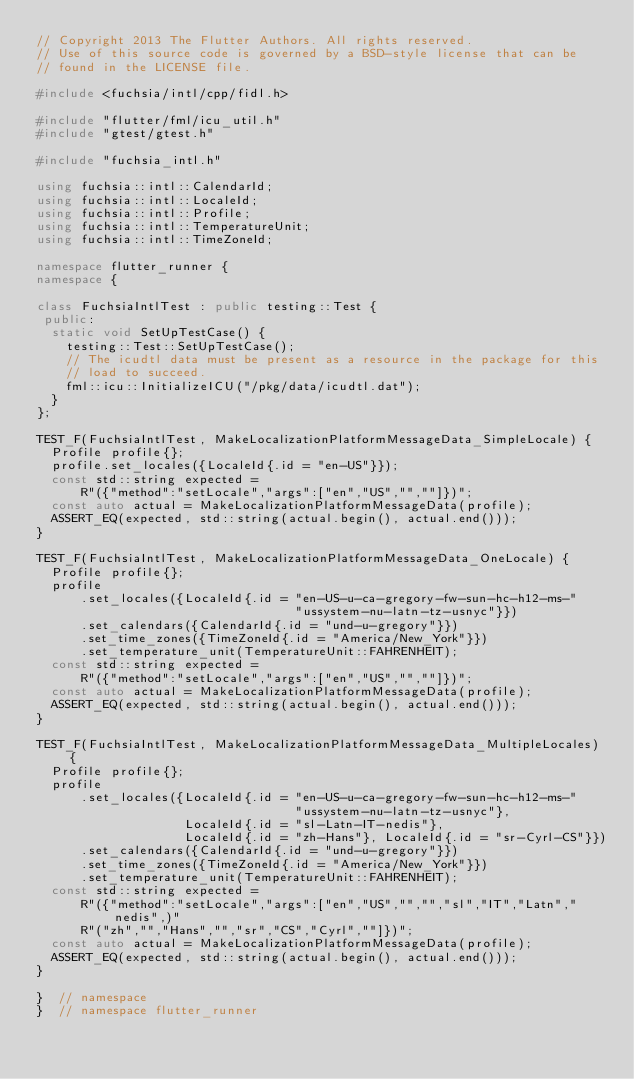Convert code to text. <code><loc_0><loc_0><loc_500><loc_500><_C++_>// Copyright 2013 The Flutter Authors. All rights reserved.
// Use of this source code is governed by a BSD-style license that can be
// found in the LICENSE file.

#include <fuchsia/intl/cpp/fidl.h>

#include "flutter/fml/icu_util.h"
#include "gtest/gtest.h"

#include "fuchsia_intl.h"

using fuchsia::intl::CalendarId;
using fuchsia::intl::LocaleId;
using fuchsia::intl::Profile;
using fuchsia::intl::TemperatureUnit;
using fuchsia::intl::TimeZoneId;

namespace flutter_runner {
namespace {

class FuchsiaIntlTest : public testing::Test {
 public:
  static void SetUpTestCase() {
    testing::Test::SetUpTestCase();
    // The icudtl data must be present as a resource in the package for this
    // load to succeed.
    fml::icu::InitializeICU("/pkg/data/icudtl.dat");
  }
};

TEST_F(FuchsiaIntlTest, MakeLocalizationPlatformMessageData_SimpleLocale) {
  Profile profile{};
  profile.set_locales({LocaleId{.id = "en-US"}});
  const std::string expected =
      R"({"method":"setLocale","args":["en","US","",""]})";
  const auto actual = MakeLocalizationPlatformMessageData(profile);
  ASSERT_EQ(expected, std::string(actual.begin(), actual.end()));
}

TEST_F(FuchsiaIntlTest, MakeLocalizationPlatformMessageData_OneLocale) {
  Profile profile{};
  profile
      .set_locales({LocaleId{.id = "en-US-u-ca-gregory-fw-sun-hc-h12-ms-"
                                   "ussystem-nu-latn-tz-usnyc"}})
      .set_calendars({CalendarId{.id = "und-u-gregory"}})
      .set_time_zones({TimeZoneId{.id = "America/New_York"}})
      .set_temperature_unit(TemperatureUnit::FAHRENHEIT);
  const std::string expected =
      R"({"method":"setLocale","args":["en","US","",""]})";
  const auto actual = MakeLocalizationPlatformMessageData(profile);
  ASSERT_EQ(expected, std::string(actual.begin(), actual.end()));
}

TEST_F(FuchsiaIntlTest, MakeLocalizationPlatformMessageData_MultipleLocales) {
  Profile profile{};
  profile
      .set_locales({LocaleId{.id = "en-US-u-ca-gregory-fw-sun-hc-h12-ms-"
                                   "ussystem-nu-latn-tz-usnyc"},
                    LocaleId{.id = "sl-Latn-IT-nedis"},
                    LocaleId{.id = "zh-Hans"}, LocaleId{.id = "sr-Cyrl-CS"}})
      .set_calendars({CalendarId{.id = "und-u-gregory"}})
      .set_time_zones({TimeZoneId{.id = "America/New_York"}})
      .set_temperature_unit(TemperatureUnit::FAHRENHEIT);
  const std::string expected =
      R"({"method":"setLocale","args":["en","US","","","sl","IT","Latn","nedis",)"
      R"("zh","","Hans","","sr","CS","Cyrl",""]})";
  const auto actual = MakeLocalizationPlatformMessageData(profile);
  ASSERT_EQ(expected, std::string(actual.begin(), actual.end()));
}

}  // namespace
}  // namespace flutter_runner
</code> 